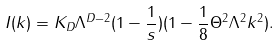<formula> <loc_0><loc_0><loc_500><loc_500>I ( k ) = K _ { D } \Lambda ^ { D - 2 } ( 1 - \frac { 1 } { s } ) ( 1 - \frac { 1 } { 8 } \Theta ^ { 2 } \Lambda ^ { 2 } k ^ { 2 } ) .</formula> 